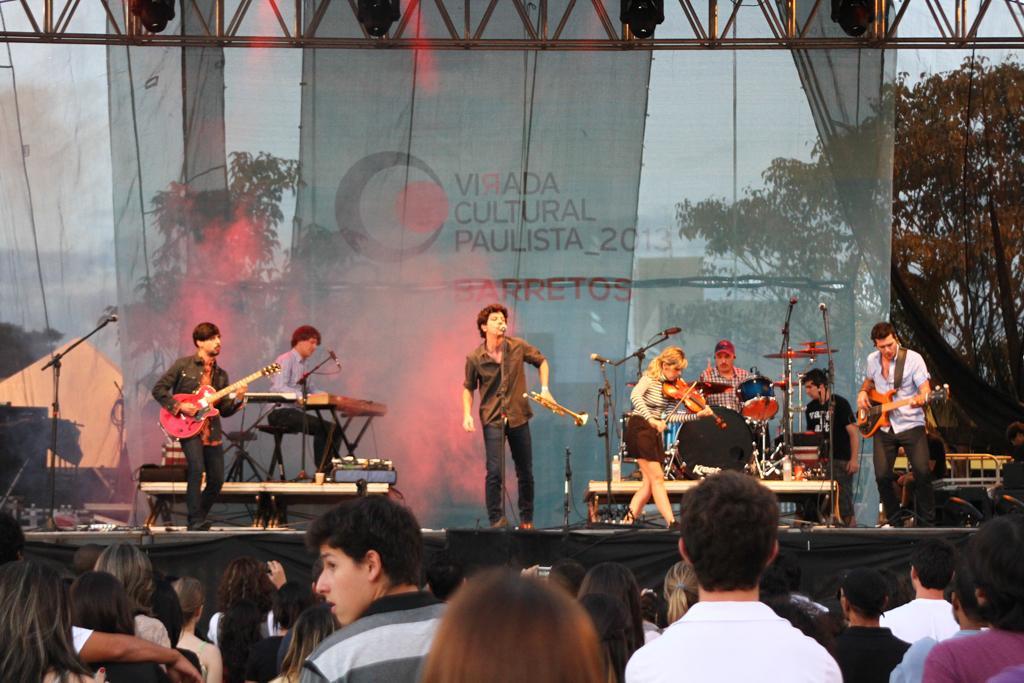Could you give a brief overview of what you see in this image? In this picture there are group of people who are playing musical instruments. There are group of people who are watching them. 